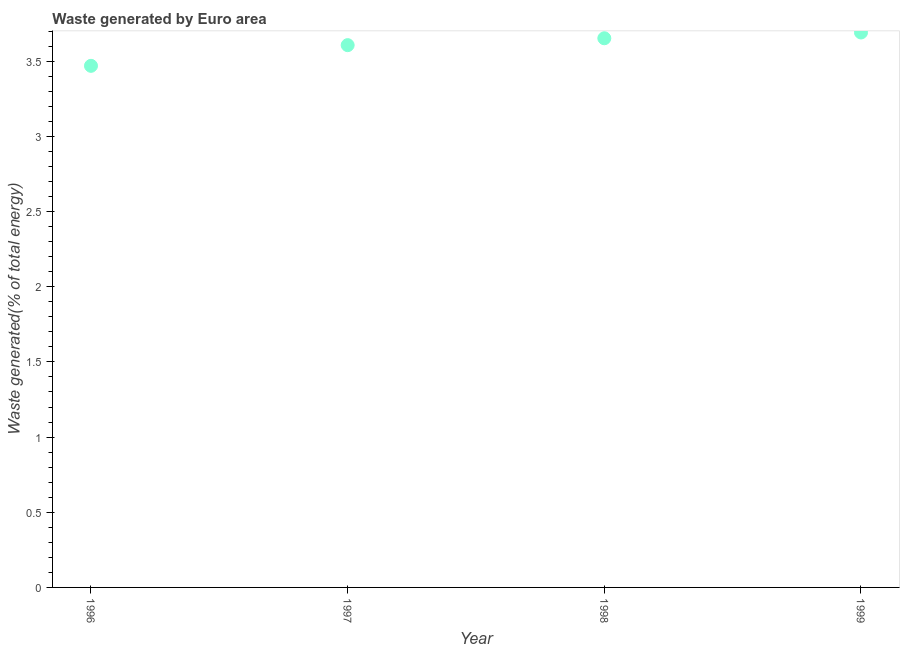What is the amount of waste generated in 1998?
Keep it short and to the point. 3.65. Across all years, what is the maximum amount of waste generated?
Offer a terse response. 3.69. Across all years, what is the minimum amount of waste generated?
Offer a terse response. 3.47. In which year was the amount of waste generated maximum?
Provide a succinct answer. 1999. In which year was the amount of waste generated minimum?
Keep it short and to the point. 1996. What is the sum of the amount of waste generated?
Your answer should be compact. 14.42. What is the difference between the amount of waste generated in 1997 and 1999?
Offer a very short reply. -0.08. What is the average amount of waste generated per year?
Ensure brevity in your answer.  3.61. What is the median amount of waste generated?
Ensure brevity in your answer.  3.63. Do a majority of the years between 1997 and 1998 (inclusive) have amount of waste generated greater than 0.6 %?
Offer a terse response. Yes. What is the ratio of the amount of waste generated in 1997 to that in 1998?
Provide a short and direct response. 0.99. Is the difference between the amount of waste generated in 1996 and 1999 greater than the difference between any two years?
Your response must be concise. Yes. What is the difference between the highest and the second highest amount of waste generated?
Your answer should be very brief. 0.04. Is the sum of the amount of waste generated in 1996 and 1997 greater than the maximum amount of waste generated across all years?
Give a very brief answer. Yes. What is the difference between the highest and the lowest amount of waste generated?
Offer a very short reply. 0.22. Does the amount of waste generated monotonically increase over the years?
Offer a terse response. Yes. How many years are there in the graph?
Your response must be concise. 4. Are the values on the major ticks of Y-axis written in scientific E-notation?
Give a very brief answer. No. Does the graph contain any zero values?
Keep it short and to the point. No. Does the graph contain grids?
Your response must be concise. No. What is the title of the graph?
Ensure brevity in your answer.  Waste generated by Euro area. What is the label or title of the X-axis?
Your answer should be compact. Year. What is the label or title of the Y-axis?
Your response must be concise. Waste generated(% of total energy). What is the Waste generated(% of total energy) in 1996?
Ensure brevity in your answer.  3.47. What is the Waste generated(% of total energy) in 1997?
Your answer should be compact. 3.61. What is the Waste generated(% of total energy) in 1998?
Make the answer very short. 3.65. What is the Waste generated(% of total energy) in 1999?
Offer a terse response. 3.69. What is the difference between the Waste generated(% of total energy) in 1996 and 1997?
Your answer should be compact. -0.14. What is the difference between the Waste generated(% of total energy) in 1996 and 1998?
Offer a very short reply. -0.18. What is the difference between the Waste generated(% of total energy) in 1996 and 1999?
Your answer should be very brief. -0.22. What is the difference between the Waste generated(% of total energy) in 1997 and 1998?
Give a very brief answer. -0.05. What is the difference between the Waste generated(% of total energy) in 1997 and 1999?
Make the answer very short. -0.08. What is the difference between the Waste generated(% of total energy) in 1998 and 1999?
Your answer should be very brief. -0.04. What is the ratio of the Waste generated(% of total energy) in 1996 to that in 1999?
Your answer should be very brief. 0.94. What is the ratio of the Waste generated(% of total energy) in 1997 to that in 1998?
Give a very brief answer. 0.99. 